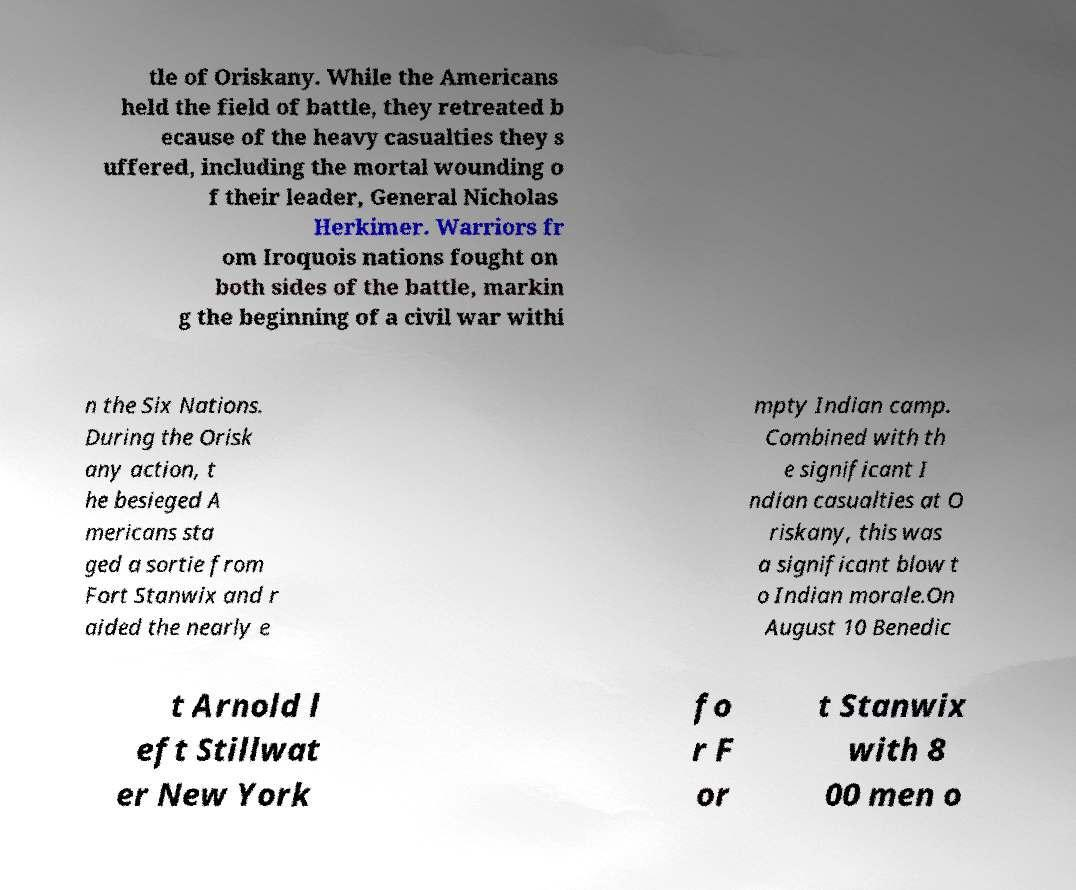Could you assist in decoding the text presented in this image and type it out clearly? tle of Oriskany. While the Americans held the field of battle, they retreated b ecause of the heavy casualties they s uffered, including the mortal wounding o f their leader, General Nicholas Herkimer. Warriors fr om Iroquois nations fought on both sides of the battle, markin g the beginning of a civil war withi n the Six Nations. During the Orisk any action, t he besieged A mericans sta ged a sortie from Fort Stanwix and r aided the nearly e mpty Indian camp. Combined with th e significant I ndian casualties at O riskany, this was a significant blow t o Indian morale.On August 10 Benedic t Arnold l eft Stillwat er New York fo r F or t Stanwix with 8 00 men o 